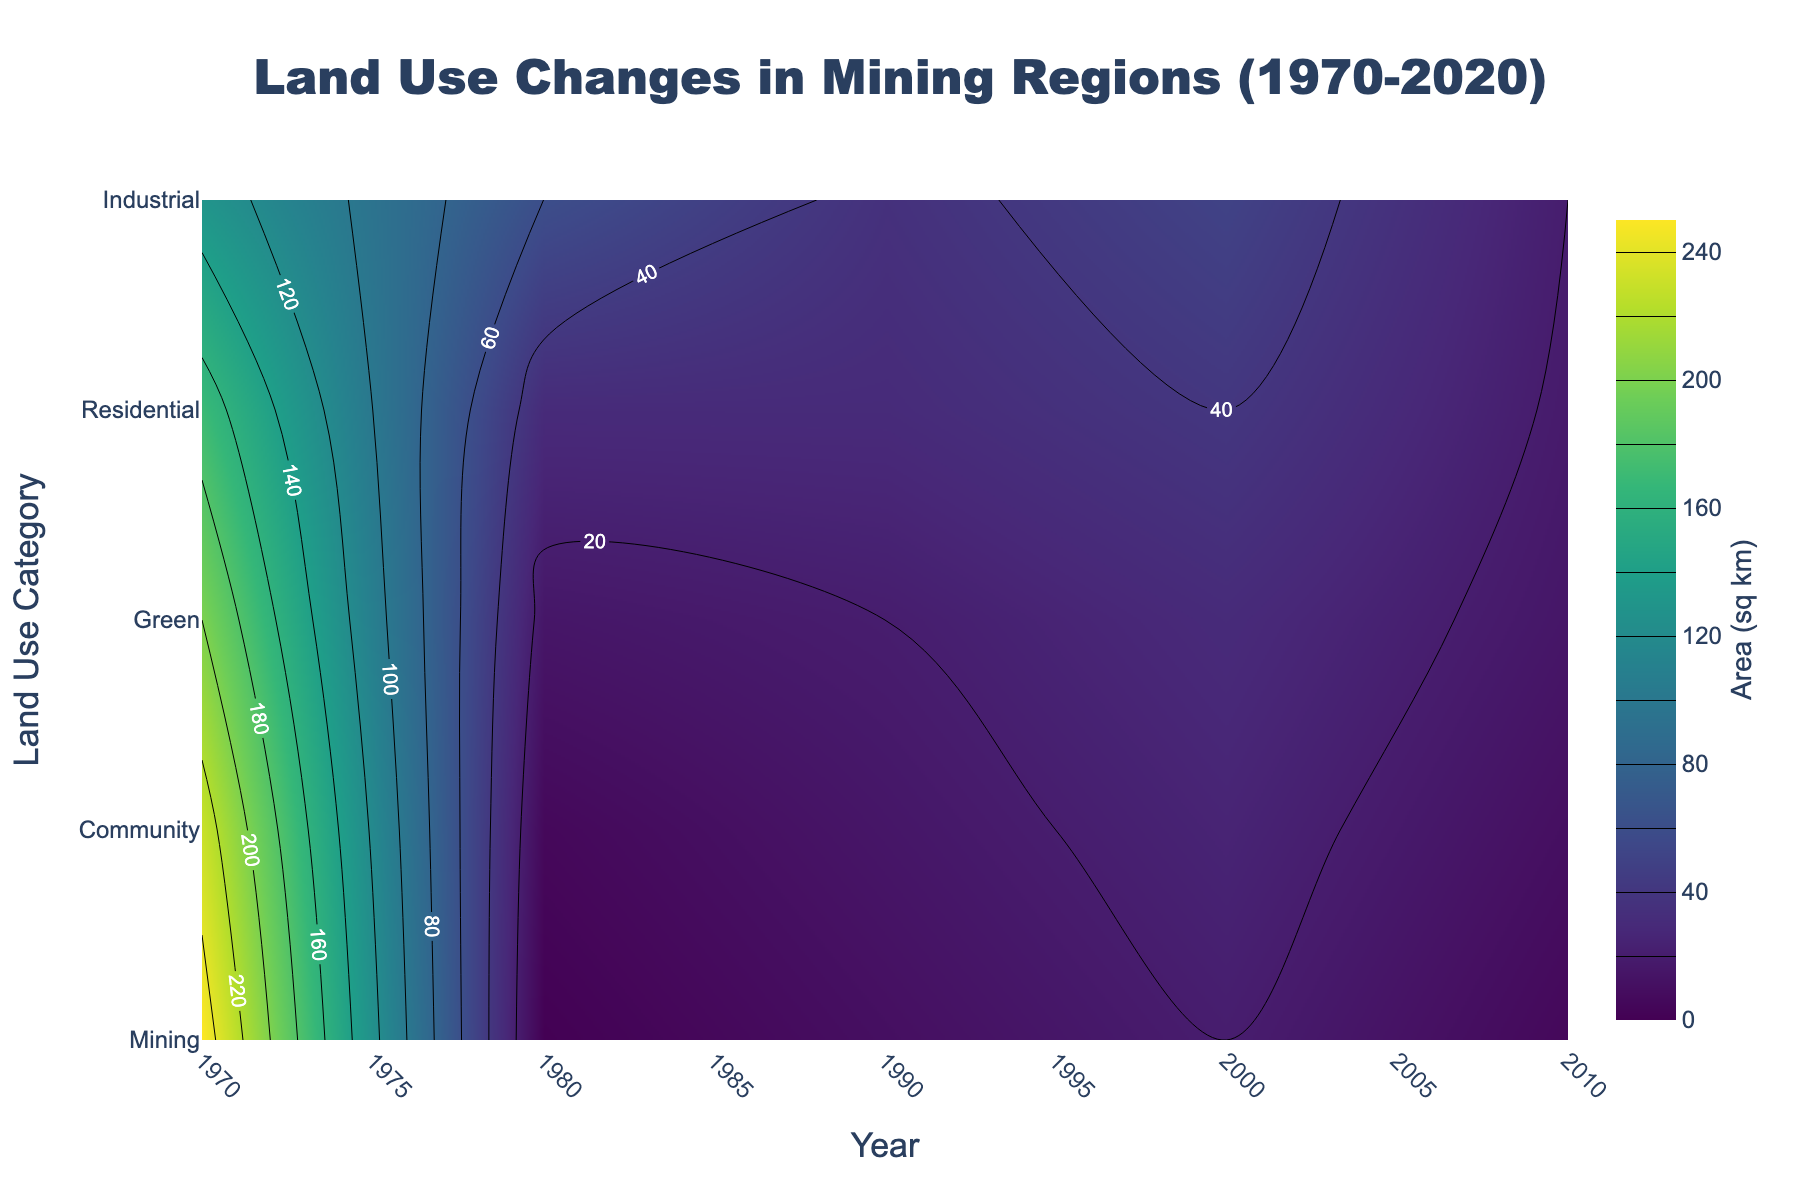What is the title of the plot? The title is located at the top center of the plot and is written in a larger font. The plot's title is "Land Use Changes in Mining Regions (1970-2020)".
Answer: Land Use Changes in Mining Regions (1970-2020) What are the x-axis and y-axis labels in this plot? The x-axis label represents the time period, or "Year", and the y-axis label represents different land use categories, labeled as "Land Use Category".
Answer: Year; Land Use Category Which land use category has the highest area in Appalachia in 2020? To find this, look along the 2020 mark on the x-axis and examine the contour levels for different land use categories on the y-axis. The category with the highest contour value in 2020 is "Community" with an area of 90 sq km.
Answer: Community By how much did the mining area decrease in Appalachia from 1970 to 2020? In 1970, the mining area in Appalachia was 250 sq km. By 2020, it reduced to 100 sq km. The difference is 250 - 100 = 150 sq km.
Answer: 150 sq km Which region had a greater expansion in community project areas over the years shown, Appalachia or Yorkshire? Compare the final values for community project areas in 2020. For Appalachia, it increased from 0 to 90 sq km, and for Yorkshire, it increased from 0 to 80 sq km. Appalachia had a greater expansion.
Answer: Appalachia What year did the residential area in Appalachia surpass 30 sq km? Examine the contours for the "Residential" category in Appalachia. The residential area surpassed 30 sq km in the year 2000.
Answer: 2000 In Yorkshire, which land use category saw a reduction in area from 1990 to 2000? Look at Yorkshire's data for 1990 and 2000. The industrial area decreased from 25 sq km in 1990 to 20 sq km in 2000.
Answer: Industrial Which region has more green space in 2020? Compare the green space contour values in 2020 for both regions. Both have 40 sq km of green space in 2020.
Answer: Both are equal What is the overall trend of industrial area in Appalachia from 1970 to 2020? By examining the contour levels for industrial area in Appalachia across the years, it's evident that the industrial area increased from 5 sq km in 1970 to 20 sq km in 2010 and then slightly decreased to 18 sq km in 2020.
Answer: Increasing then slight decrease 